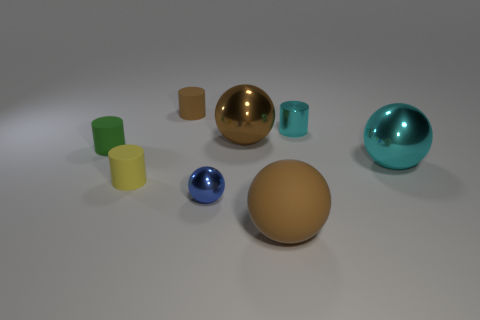Are the small thing that is on the right side of the brown matte ball and the cylinder in front of the small green cylinder made of the same material?
Give a very brief answer. No. Is the number of big metallic spheres in front of the tiny metallic ball the same as the number of big brown matte balls behind the rubber sphere?
Provide a short and direct response. Yes. There is a small yellow cylinder in front of the green rubber thing; what is it made of?
Your answer should be compact. Rubber. Is there anything else that is the same size as the green matte cylinder?
Keep it short and to the point. Yes. Is the number of cyan shiny balls less than the number of big blue cylinders?
Offer a terse response. No. What shape is the brown thing that is behind the green matte thing and on the right side of the tiny blue metallic ball?
Your answer should be very brief. Sphere. What number of tiny objects are there?
Your answer should be very brief. 5. There is a big brown ball that is right of the brown sphere that is behind the small yellow rubber object on the left side of the tiny brown rubber object; what is it made of?
Provide a short and direct response. Rubber. There is a brown matte object to the left of the big rubber object; what number of small matte things are on the left side of it?
Provide a short and direct response. 2. There is another shiny object that is the same shape as the green object; what is its color?
Offer a very short reply. Cyan. 